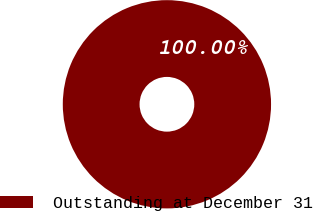<chart> <loc_0><loc_0><loc_500><loc_500><pie_chart><fcel>Outstanding at December 31<nl><fcel>100.0%<nl></chart> 